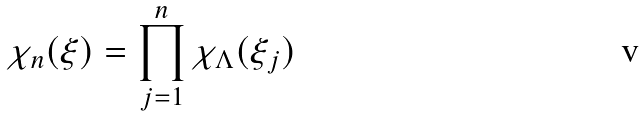<formula> <loc_0><loc_0><loc_500><loc_500>\chi _ { n } ( \xi ) = \prod _ { j = 1 } ^ { n } \chi _ { \Lambda } ( \xi _ { j } )</formula> 